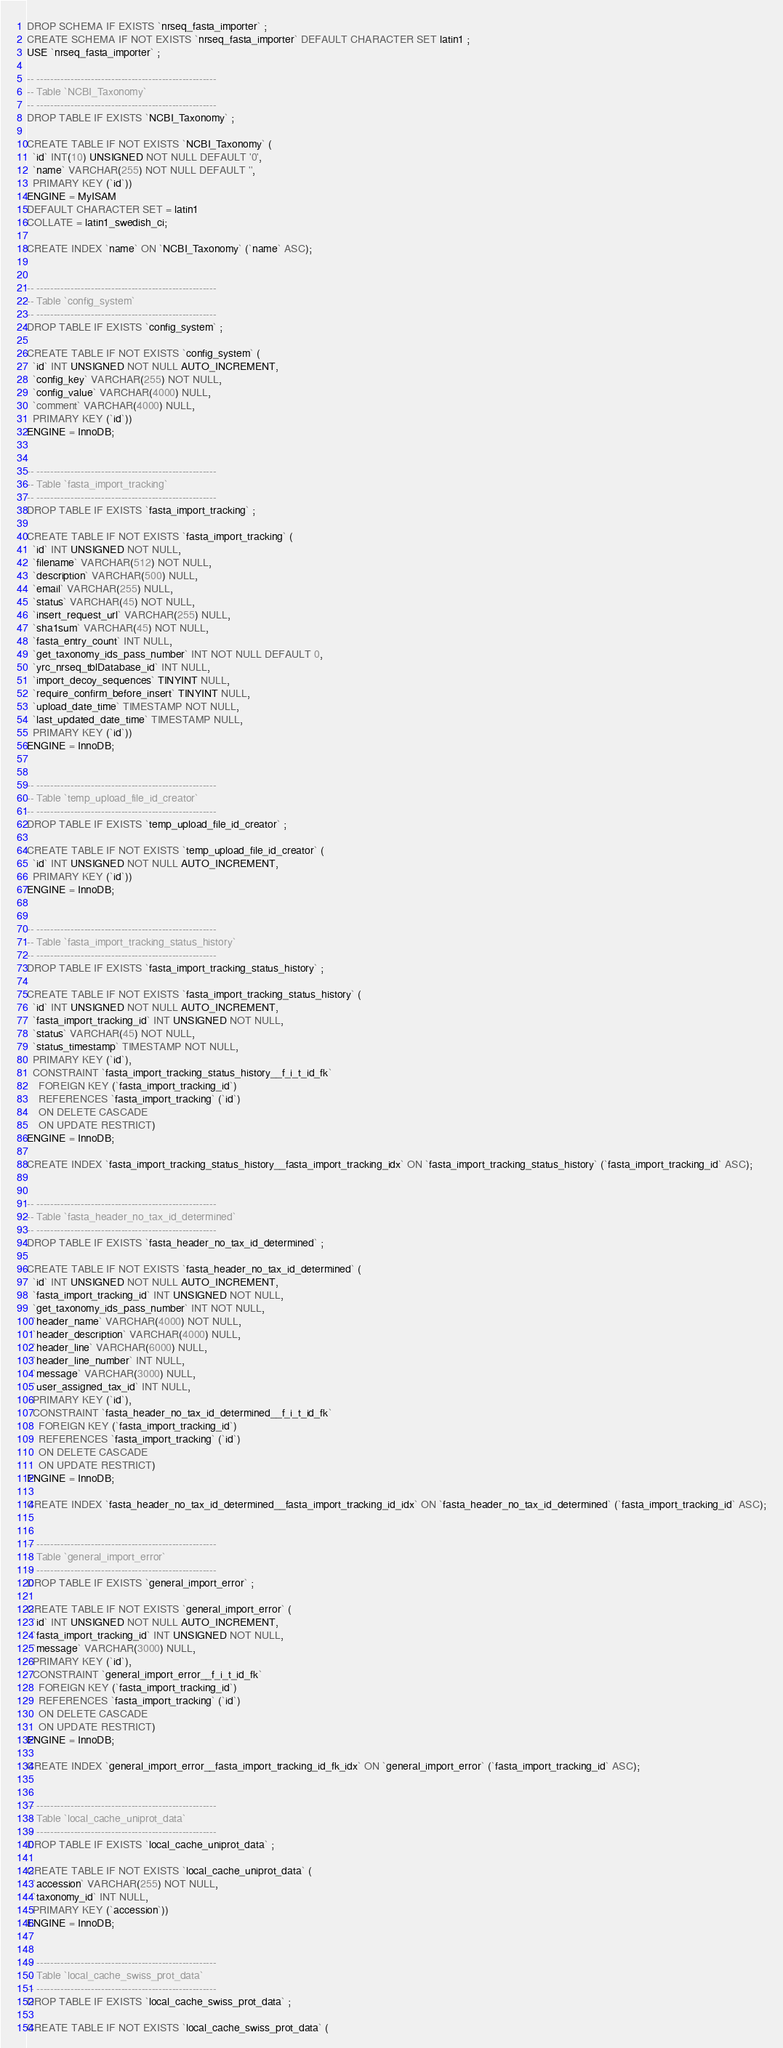<code> <loc_0><loc_0><loc_500><loc_500><_SQL_>
DROP SCHEMA IF EXISTS `nrseq_fasta_importer` ;
CREATE SCHEMA IF NOT EXISTS `nrseq_fasta_importer` DEFAULT CHARACTER SET latin1 ;
USE `nrseq_fasta_importer` ;

-- -----------------------------------------------------
-- Table `NCBI_Taxonomy`
-- -----------------------------------------------------
DROP TABLE IF EXISTS `NCBI_Taxonomy` ;

CREATE TABLE IF NOT EXISTS `NCBI_Taxonomy` (
  `id` INT(10) UNSIGNED NOT NULL DEFAULT '0',
  `name` VARCHAR(255) NOT NULL DEFAULT '',
  PRIMARY KEY (`id`))
ENGINE = MyISAM
DEFAULT CHARACTER SET = latin1
COLLATE = latin1_swedish_ci;

CREATE INDEX `name` ON `NCBI_Taxonomy` (`name` ASC);


-- -----------------------------------------------------
-- Table `config_system`
-- -----------------------------------------------------
DROP TABLE IF EXISTS `config_system` ;

CREATE TABLE IF NOT EXISTS `config_system` (
  `id` INT UNSIGNED NOT NULL AUTO_INCREMENT,
  `config_key` VARCHAR(255) NOT NULL,
  `config_value` VARCHAR(4000) NULL,
  `comment` VARCHAR(4000) NULL,
  PRIMARY KEY (`id`))
ENGINE = InnoDB;


-- -----------------------------------------------------
-- Table `fasta_import_tracking`
-- -----------------------------------------------------
DROP TABLE IF EXISTS `fasta_import_tracking` ;

CREATE TABLE IF NOT EXISTS `fasta_import_tracking` (
  `id` INT UNSIGNED NOT NULL,
  `filename` VARCHAR(512) NOT NULL,
  `description` VARCHAR(500) NULL,
  `email` VARCHAR(255) NULL,
  `status` VARCHAR(45) NOT NULL,
  `insert_request_url` VARCHAR(255) NULL,
  `sha1sum` VARCHAR(45) NOT NULL,
  `fasta_entry_count` INT NULL,
  `get_taxonomy_ids_pass_number` INT NOT NULL DEFAULT 0,
  `yrc_nrseq_tblDatabase_id` INT NULL,
  `import_decoy_sequences` TINYINT NULL,
  `require_confirm_before_insert` TINYINT NULL,
  `upload_date_time` TIMESTAMP NOT NULL,
  `last_updated_date_time` TIMESTAMP NULL,
  PRIMARY KEY (`id`))
ENGINE = InnoDB;


-- -----------------------------------------------------
-- Table `temp_upload_file_id_creator`
-- -----------------------------------------------------
DROP TABLE IF EXISTS `temp_upload_file_id_creator` ;

CREATE TABLE IF NOT EXISTS `temp_upload_file_id_creator` (
  `id` INT UNSIGNED NOT NULL AUTO_INCREMENT,
  PRIMARY KEY (`id`))
ENGINE = InnoDB;


-- -----------------------------------------------------
-- Table `fasta_import_tracking_status_history`
-- -----------------------------------------------------
DROP TABLE IF EXISTS `fasta_import_tracking_status_history` ;

CREATE TABLE IF NOT EXISTS `fasta_import_tracking_status_history` (
  `id` INT UNSIGNED NOT NULL AUTO_INCREMENT,
  `fasta_import_tracking_id` INT UNSIGNED NOT NULL,
  `status` VARCHAR(45) NOT NULL,
  `status_timestamp` TIMESTAMP NOT NULL,
  PRIMARY KEY (`id`),
  CONSTRAINT `fasta_import_tracking_status_history__f_i_t_id_fk`
    FOREIGN KEY (`fasta_import_tracking_id`)
    REFERENCES `fasta_import_tracking` (`id`)
    ON DELETE CASCADE
    ON UPDATE RESTRICT)
ENGINE = InnoDB;

CREATE INDEX `fasta_import_tracking_status_history__fasta_import_tracking_idx` ON `fasta_import_tracking_status_history` (`fasta_import_tracking_id` ASC);


-- -----------------------------------------------------
-- Table `fasta_header_no_tax_id_determined`
-- -----------------------------------------------------
DROP TABLE IF EXISTS `fasta_header_no_tax_id_determined` ;

CREATE TABLE IF NOT EXISTS `fasta_header_no_tax_id_determined` (
  `id` INT UNSIGNED NOT NULL AUTO_INCREMENT,
  `fasta_import_tracking_id` INT UNSIGNED NOT NULL,
  `get_taxonomy_ids_pass_number` INT NOT NULL,
  `header_name` VARCHAR(4000) NOT NULL,
  `header_description` VARCHAR(4000) NULL,
  `header_line` VARCHAR(6000) NULL,
  `header_line_number` INT NULL,
  `message` VARCHAR(3000) NULL,
  `user_assigned_tax_id` INT NULL,
  PRIMARY KEY (`id`),
  CONSTRAINT `fasta_header_no_tax_id_determined__f_i_t_id_fk`
    FOREIGN KEY (`fasta_import_tracking_id`)
    REFERENCES `fasta_import_tracking` (`id`)
    ON DELETE CASCADE
    ON UPDATE RESTRICT)
ENGINE = InnoDB;

CREATE INDEX `fasta_header_no_tax_id_determined__fasta_import_tracking_id_idx` ON `fasta_header_no_tax_id_determined` (`fasta_import_tracking_id` ASC);


-- -----------------------------------------------------
-- Table `general_import_error`
-- -----------------------------------------------------
DROP TABLE IF EXISTS `general_import_error` ;

CREATE TABLE IF NOT EXISTS `general_import_error` (
  `id` INT UNSIGNED NOT NULL AUTO_INCREMENT,
  `fasta_import_tracking_id` INT UNSIGNED NOT NULL,
  `message` VARCHAR(3000) NULL,
  PRIMARY KEY (`id`),
  CONSTRAINT `general_import_error__f_i_t_id_fk`
    FOREIGN KEY (`fasta_import_tracking_id`)
    REFERENCES `fasta_import_tracking` (`id`)
    ON DELETE CASCADE
    ON UPDATE RESTRICT)
ENGINE = InnoDB;

CREATE INDEX `general_import_error__fasta_import_tracking_id_fk_idx` ON `general_import_error` (`fasta_import_tracking_id` ASC);


-- -----------------------------------------------------
-- Table `local_cache_uniprot_data`
-- -----------------------------------------------------
DROP TABLE IF EXISTS `local_cache_uniprot_data` ;

CREATE TABLE IF NOT EXISTS `local_cache_uniprot_data` (
  `accession` VARCHAR(255) NOT NULL,
  `taxonomy_id` INT NULL,
  PRIMARY KEY (`accession`))
ENGINE = InnoDB;


-- -----------------------------------------------------
-- Table `local_cache_swiss_prot_data`
-- -----------------------------------------------------
DROP TABLE IF EXISTS `local_cache_swiss_prot_data` ;

CREATE TABLE IF NOT EXISTS `local_cache_swiss_prot_data` (</code> 